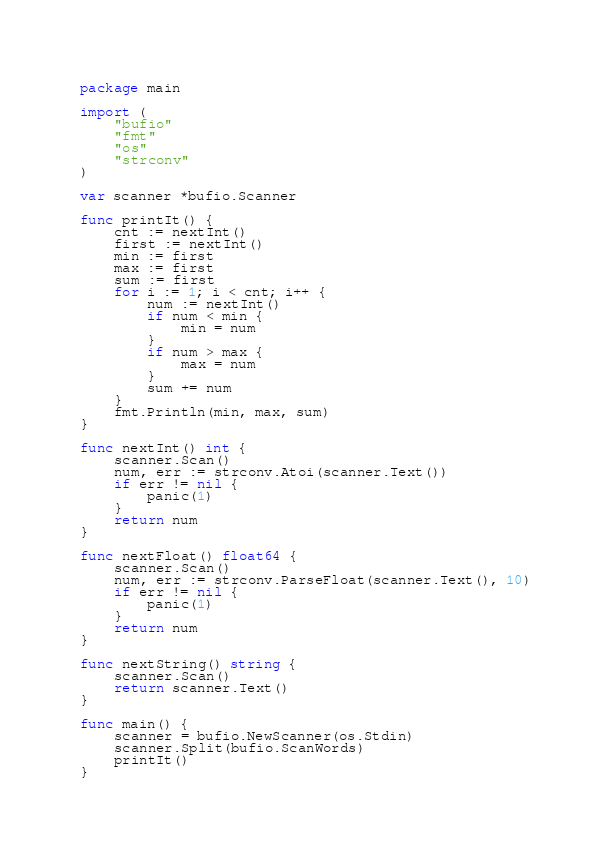Convert code to text. <code><loc_0><loc_0><loc_500><loc_500><_Go_>package main

import (
	"bufio"
	"fmt"
	"os"
	"strconv"
)

var scanner *bufio.Scanner

func printIt() {
	cnt := nextInt()
	first := nextInt()
	min := first
	max := first
	sum := first
	for i := 1; i < cnt; i++ {
		num := nextInt()
		if num < min {
			min = num
		}
		if num > max {
			max = num
		}
		sum += num
	}
	fmt.Println(min, max, sum)
}

func nextInt() int {
	scanner.Scan()
	num, err := strconv.Atoi(scanner.Text())
	if err != nil {
		panic(1)
	}
	return num
}

func nextFloat() float64 {
	scanner.Scan()
	num, err := strconv.ParseFloat(scanner.Text(), 10)
	if err != nil {
		panic(1)
	}
	return num
}

func nextString() string {
	scanner.Scan()
	return scanner.Text()
}

func main() {
	scanner = bufio.NewScanner(os.Stdin)
	scanner.Split(bufio.ScanWords)
	printIt()
}

</code> 